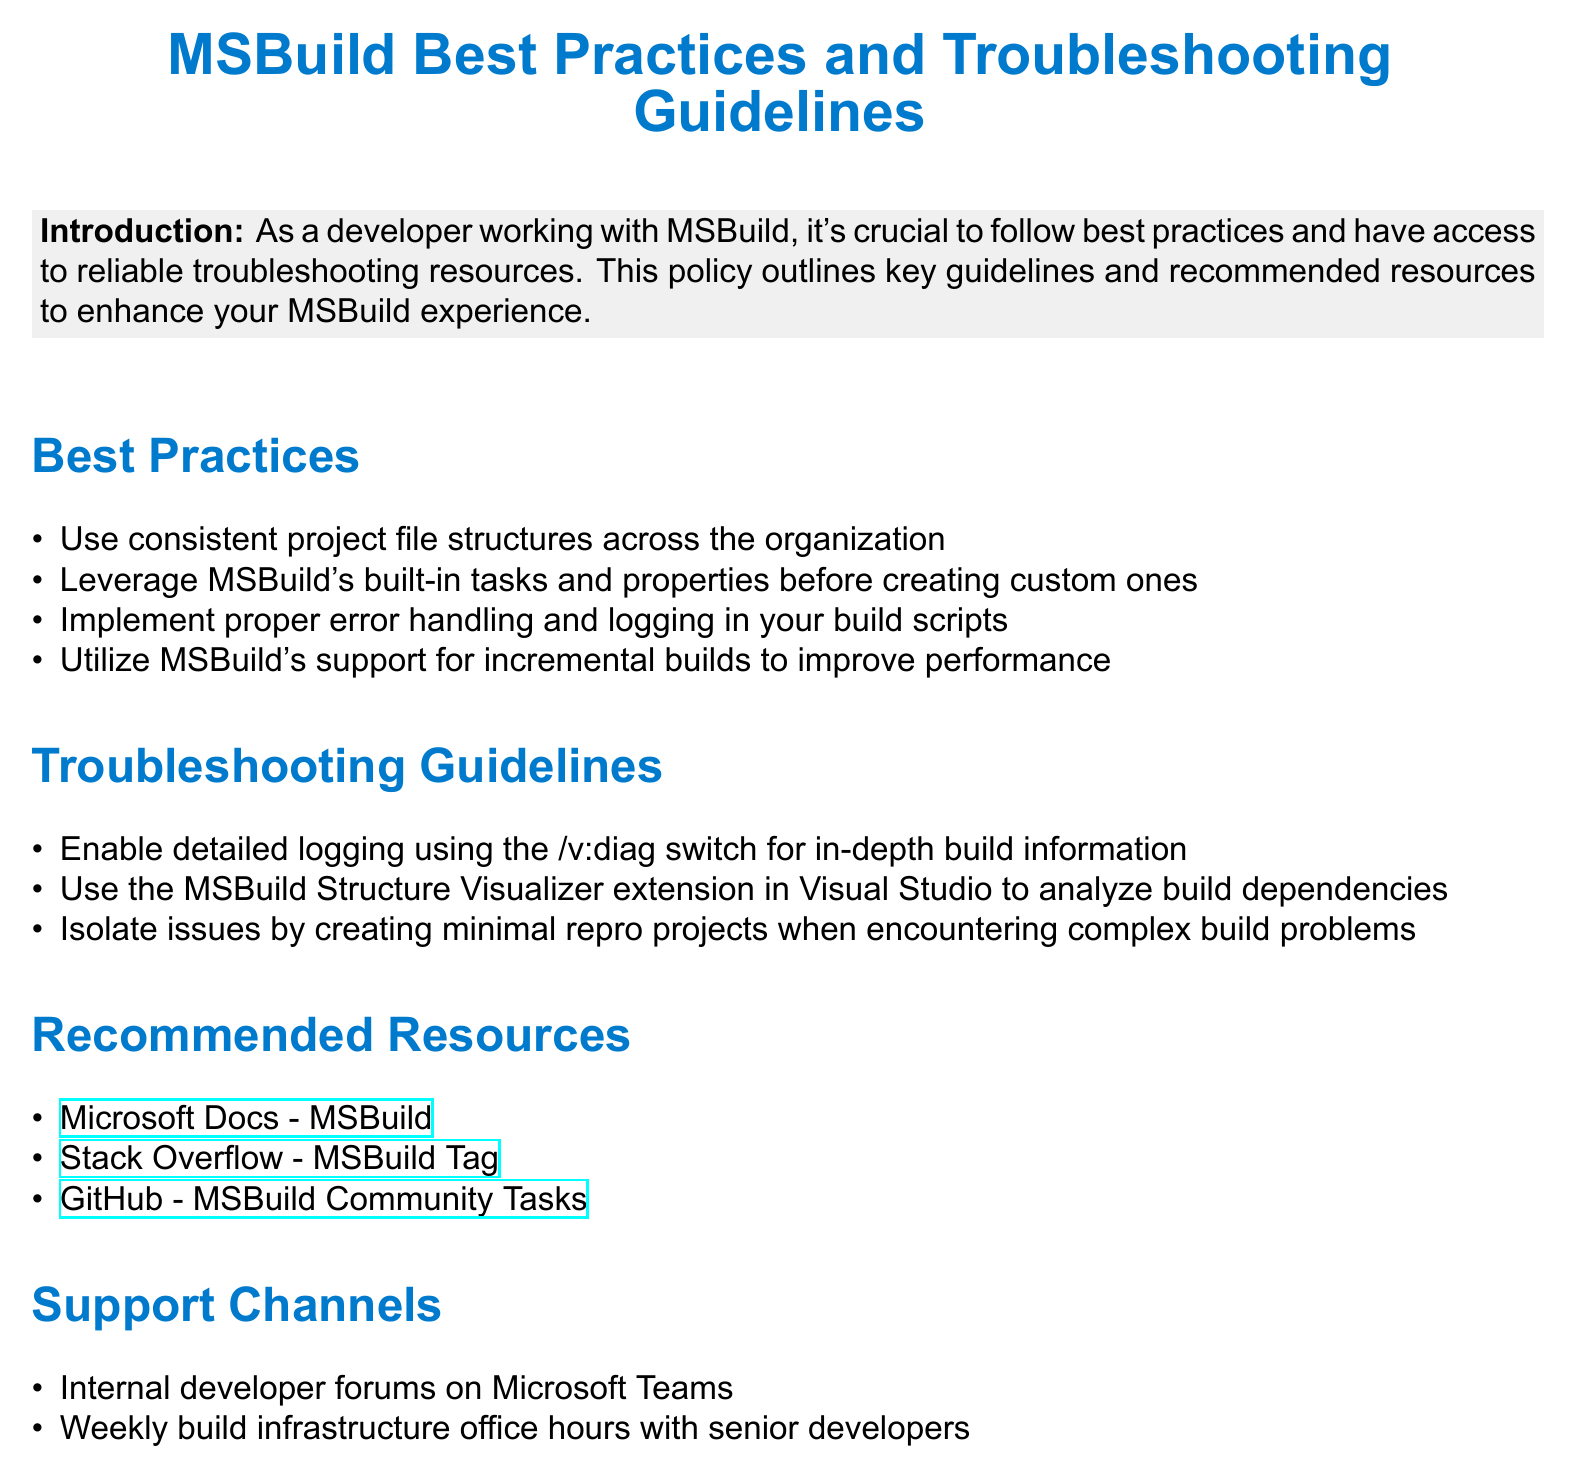What is the title of the document? The title of the document is presented prominently at the top of the rendered document.
Answer: MSBuild Best Practices and Troubleshooting Guidelines What is one of the best practices listed? The document outlines several best practices for using MSBuild.
Answer: Use consistent project file structures across the organization How many troubleshooting guidelines are provided? The document enumerates troubleshooting guidelines, which can be counted.
Answer: Three Where can you find the MSBuild Community Tasks? The document provides a specific online resource location for community tasks.
Answer: GitHub - MSBuild Community Tasks What switch is suggested for enabling detailed logging? The document mentions a specific switch used for logging during troubleshooting.
Answer: /v:diag What section follows the Best Practices in the document? The structure of the document is sequential, detailing sections in order.
Answer: Troubleshooting Guidelines What is the purpose of the Internal developer forums mentioned? The document identifies support channels for developers, where they can seek help.
Answer: Support channel How does MSBuild improve performance according to the document? The document highlights a specific built-in feature aimed at performance enhancement.
Answer: Incremental builds 